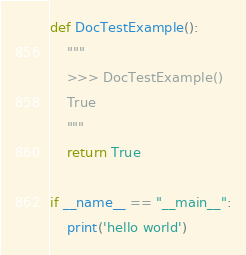Convert code to text. <code><loc_0><loc_0><loc_500><loc_500><_Python_>
def DocTestExample():
    """
    >>> DocTestExample()
    True
    """
    return True

if __name__ == "__main__":
    print('hello world')</code> 